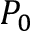<formula> <loc_0><loc_0><loc_500><loc_500>P _ { 0 }</formula> 